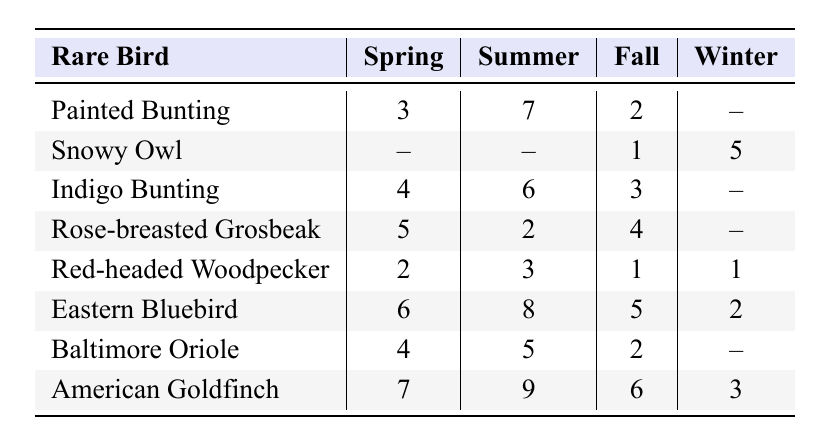What is the highest number of sightings for the Painted Bunting? In the table, under the Summer column, the sightings for the Painted Bunting is 7, which is the highest number of sightings for this bird across all seasons.
Answer: 7 Which rare bird was sighted during Winter season? The table shows that the Snowy Owl and the Red-headed Woodpecker were sighted in Winter, with 5 sightings for the Snowy Owl and 1 for the Red-headed Woodpecker.
Answer: Snowy Owl, Red-headed Woodpecker How many rare birds had sightings in Spring? By checking each row in the Spring column, there are 5 birds with sightings (Painted Bunting: 3, Indigo Bunting: 4, Rose-breasted Grosbeak: 5, Red-headed Woodpecker: 2, Eastern Bluebird: 6, Baltimore Oriole: 4, American Goldfinch: 7). The Snowy Owl and the Rose-breasted Grosbeak do not have sightings in Spring (marked as --). Hence, there are 6 birds in total that were sighted in Spring.
Answer: 6 What is the average number of sightings for the Eastern Bluebird across all seasons? The sightings for the Eastern Bluebird are 6 (Spring), 8 (Summer), 5 (Fall), and 2 (Winter). Adding them up gives 6 + 8 + 5 + 2 = 21. There are 4 seasons, so the average is 21 divided by 4, which equals 5.25.
Answer: 5.25 Which bird had the least sightings in Fall? In the Fall column, the sightings are: Painted Bunting (2), Snowy Owl (1), Indigo Bunting (3), Rose-breasted Grosbeak (4), Red-headed Woodpecker (1), Eastern Bluebird (5), Baltimore Oriole (2), American Goldfinch (6). The Snowy Owl and Red-headed Woodpecker both have the least sightings of just 1 in Fall.
Answer: Snowy Owl, Red-headed Woodpecker How many more sightings did the American Goldfinch have than the Snowy Owl in Summer? In the Summer column, the American Goldfinch has 9 sightings while the Snowy Owl has 0. Therefore, the difference is 9 - 0 = 9 sightings.
Answer: 9 Did any birds have sightings in Winter? In the Winter column, the Snowy Owl and Red-headed Woodpecker have sightings of 5 and 1 respectively. Therefore, yes, these birds were seen in Winter.
Answer: Yes What is the total number of sightings for the American Goldfinch across all seasons? The American Goldfinch has sightings of 7 (Spring), 9 (Summer), 6 (Fall), and 3 (Winter). By adding these, we get 7 + 9 + 6 + 3 = 25 total sightings.
Answer: 25 Which season had the highest overall bird sightings? To find this, we sum up the sightings for each season: Spring = 3 + 0 + 4 + 5 + 2 + 6 + 4 + 7 = 31, Summer = 7 + 0 + 6 + 2 + 3 + 8 + 5 + 9 = 40, Fall = 2 + 1 + 3 + 4 + 1 + 5 + 2 + 6 = 24, and Winter = 0 + 5 + 0 + 0 + 1 + 2 + 0 + 3 = 11. Summer has the highest total with 40 sightings.
Answer: Summer Which rare bird had the most consistent sightings across all seasons? To determine consistency, we look for the bird with the least variation in sightings. The Red-headed Woodpecker has sightings of 2 (Spring), 3 (Summer), 1 (Fall), and 1 (Winter), showing a variation range of just 1 to 3. This suggests a level of consistency, but also a low sighting rate overall. We also notice the Snowy Owl which has 0 in Spring and Summer but jumps to higher numbers in other seasons. Establishing consistency here is tricky, so based on the above, Red-headed Woodpecker is chosen for being close within a small range.
Answer: Red-headed Woodpecker 